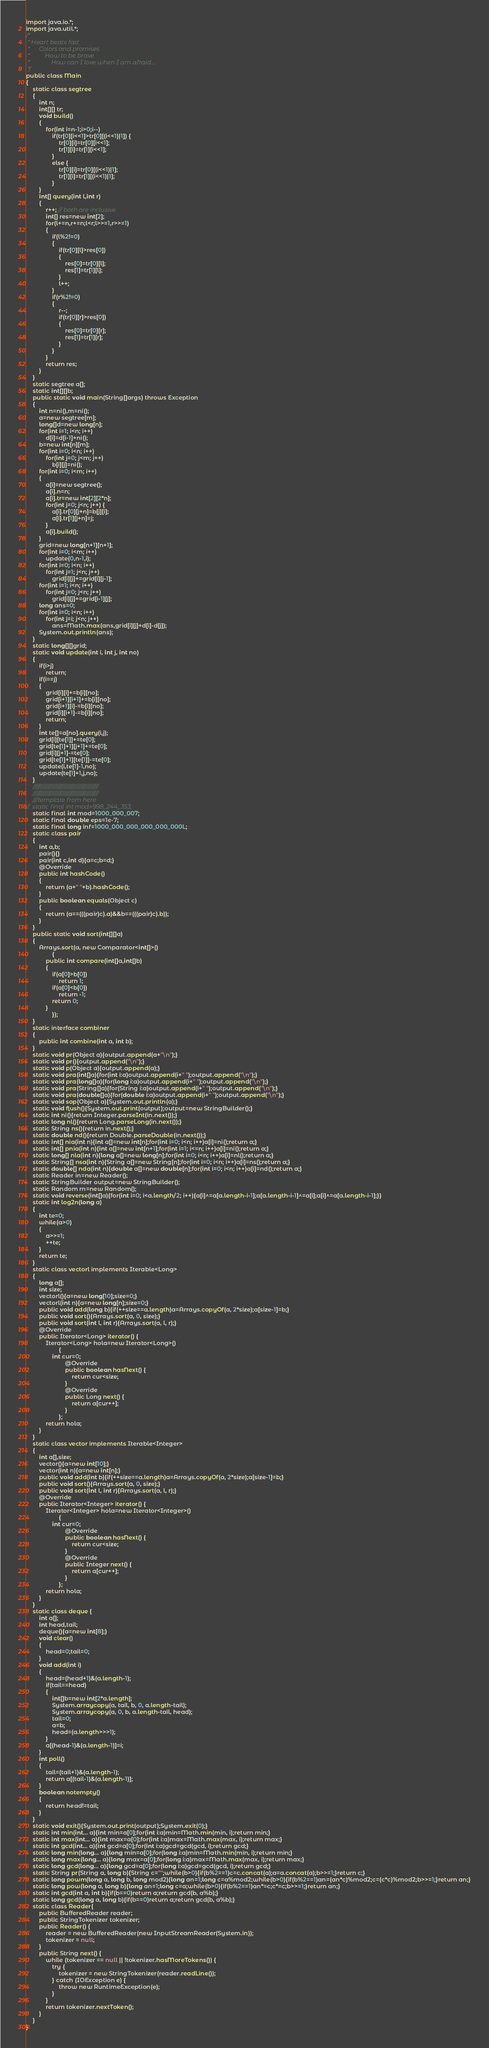Convert code to text. <code><loc_0><loc_0><loc_500><loc_500><_Java_>import java.io.*;
import java.util.*;
/*
 * Heart beats fast
 * 		Colors and promises
 * 			How to be brave
 * 				How can I love when I am afraid...
 */
public class Main
{
	static class segtree
	{ 
		int n;
		int[][] tr;
		void build()
		{
			for(int i=n-1;i>0;i--)
				if(tr[0][i<<1]>tr[0][(i<<1)|1]) {
					tr[0][i]=tr[0][i<<1];
					tr[1][i]=tr[1][i<<1];
				}
				else {
					tr[0][i]=tr[0][(i<<1)|1];
					tr[1][i]=tr[1][(i<<1)|1];	
				}
		}
		int[] query(int l,int r)
		{
			r++; // both are inclusive
			int[] res=new int[2];
			for(l+=n,r+=n;l<r;l>>=1,r>>=1)
			{
				if(l%2!=0) 
				{
					if(tr[0][l]>res[0])
					{
						res[0]=tr[0][l];
						res[1]=tr[1][l];
					}
					l++;
				}
				if(r%2!=0)
				{
					r--;
					if(tr[0][r]>res[0])
					{
						res[0]=tr[0][r];
						res[1]=tr[1][r];
					}
				}
			}
			return res;
		}
	}
	static segtree a[];
	static int[][]b;
	public static void main(String[]args) throws Exception
	{
		int n=ni(),m=ni();
		a=new segtree[m];
		long[]d=new long[n];
		for(int i=1; i<n; i++)
			d[i]=d[i-1]+ni();
		b=new int[n][m];
		for(int i=0; i<n; i++)
			for(int j=0; j<m; j++)
				b[i][j]=ni();
		for(int i=0; i<m; i++)
		{
			a[i]=new segtree();
			a[i].n=n;
			a[i].tr=new int[2][2*n];
			for(int j=0; j<n; j++) {
				a[i].tr[0][j+n]=b[j][i];
				a[i].tr[1][j+n]=j;
			}
			a[i].build();
		}
		grid=new long[n+1][n+1];
		for(int i=0; i<m; i++)
			update(0,n-1,i);
		for(int i=0; i<n; i++)
			for(int j=1; j<n; j++)
				grid[i][j]+=grid[i][j-1];
		for(int i=1; i<n; i++)
			for(int j=0; j<n; j++)
				grid[i][j]+=grid[i-1][j];
		long ans=0;
		for(int i=0; i<n; i++)
			for(int j=i; j<n; j++)
				ans=Math.max(ans,grid[i][j]+d[i]-d[j]);
		System.out.println(ans);
	}
	static long[][]grid;
	static void update(int i, int j, int no)
	{
		if(i>j)
			return;
		if(i==j)
		{
			grid[i][i]+=b[i][no];
			grid[i+1][i+1]+=b[i][no];
			grid[i+1][i]-=b[i][no];
			grid[i][i+1]-=b[i][no];
			return;
		}
		int te[]=a[no].query(i,j);
		grid[i][te[1]]+=te[0];
		grid[te[1]+1][j+1]+=te[0];
		grid[i][j+1]-=te[0];
		grid[te[1]+1][te[1]]-=te[0];
		update(i,te[1]-1,no);
		update(te[1]+1,j,no);
	}
	///////////////////////////////////////////
	///////////////////////////////////////////
	///template from here
//	static final int mod=998_244_353;
	static final int mod=1000_000_007;
	static final double eps=1e-7;
	static final long inf=1000_000_000_000_000_000L;
	static class pair
	{
		int a,b;
		pair(){}
		pair(int c,int d){a=c;b=d;}
		@Override
		public int hashCode()
		{
			return (a+" "+b).hashCode();
		}
		public boolean equals(Object c)
		{
			return (a==(((pair)c).a)&&b==(((pair)c).b));
		}
	}
	public static void sort(int[][]a)
	{
		Arrays.sort(a, new Comparator<int[]>()
				{
			public int compare(int[]a,int[]b)
			{
				if(a[0]>b[0])
					return 1;
				if(a[0]<b[0])
					return -1;
				return 0;
			}
				});
	}
	static interface combiner
	{
		public int combine(int a, int b);
	}
	static void pr(Object a){output.append(a+"\n");}
	static void pr(){output.append("\n");}
	static void p(Object a){output.append(a);}
	static void pra(int[]a){for(int i:a)output.append(i+" ");output.append("\n");}
	static void pra(long[]a){for(long i:a)output.append(i+" ");output.append("\n");}
	static void pra(String[]a){for(String i:a)output.append(i+" ");output.append("\n");}
	static void pra(double[]a){for(double i:a)output.append(i+" ");output.append("\n");}
	static void sop(Object a){System.out.println(a);}
	static void flush(){System.out.print(output);output=new StringBuilder();}
	static int ni(){return Integer.parseInt(in.next());}
	static long nl(){return Long.parseLong(in.next());}
	static String ns(){return in.next();}
	static double nd(){return Double.parseDouble(in.next());}
	static int[] nia(int n){int a[]=new int[n];for(int i=0; i<n; i++)a[i]=ni();return a;}
	static int[] pnia(int n){int a[]=new int[n+1];for(int i=1; i<=n; i++)a[i]=ni();return a;}
	static long[] nla(int n){long a[]=new long[n];for(int i=0; i<n; i++)a[i]=nl();return a;}
	static String[] nsa(int n){String a[]=new String[n];for(int i=0; i<n; i++)a[i]=ns();return a;}
	static double[] nda(int n){double a[]=new double[n];for(int i=0; i<n; i++)a[i]=nd();return a;}
	static Reader in=new Reader();
	static StringBuilder output=new StringBuilder();
	static Random rn=new Random();
	static void reverse(int[]a){for(int i=0; i<a.length/2; i++){a[i]^=a[a.length-i-1];a[a.length-i-1]^=a[i];a[i]^=a[a.length-i-1];}}
	static int log2n(long a)
	{
		int te=0;
		while(a>0)
		{
			a>>=1;
			++te;
		}
		return te;
	}
	static class vectorl implements Iterable<Long>
	{
		long a[];
		int size;
		vectorl(){a=new long[10];size=0;}
		vectorl(int n){a=new long[n];size=0;}
		public void add(long b){if(++size==a.length)a=Arrays.copyOf(a, 2*size);a[size-1]=b;}
		public void sort(){Arrays.sort(a, 0, size);}
		public void sort(int l, int r){Arrays.sort(a, l, r);}
		@Override
		public Iterator<Long> iterator() {
			Iterator<Long> hola=new Iterator<Long>()
					{
				int cur=0;
						@Override
						public boolean hasNext() {
							return cur<size;
						}
						@Override
						public Long next() {
							return a[cur++];
						}				
					};
			return hola;
		}
	}
	static class vector implements Iterable<Integer>
	{
		int a[],size;
		vector(){a=new int[10];}
		vector(int n){a=new int[n];}
		public void add(int b){if(++size==a.length)a=Arrays.copyOf(a, 2*size);a[size-1]=b;}
		public void sort(){Arrays.sort(a, 0, size);}
		public void sort(int l, int r){Arrays.sort(a, l, r);}
		@Override
		public Iterator<Integer> iterator() {
			Iterator<Integer> hola=new Iterator<Integer>()
					{
				int cur=0;
						@Override
						public boolean hasNext() {
							return cur<size;
						}
						@Override
						public Integer next() {
							return a[cur++];
						}				
					};
			return hola;
		}
	}
	static class deque {
		int a[];
		int head,tail;
		deque(){a=new int[8];}
		void clear()
		{
			head=0;tail=0;
		}
		void add(int i)
		{	
			head=(head+1)&(a.length-1);
			if(tail==head)
			{
				int[]b=new int[2*a.length];
				System.arraycopy(a, tail, b, 0, a.length-tail);
				System.arraycopy(a, 0, b, a.length-tail, head);
				tail=0;
				a=b;
				head=(a.length>>>1);
			}
			a[(head-1)&(a.length-1)]=i;
		}
		int poll()
		{
			tail=(tail+1)&(a.length-1);
			return a[(tail-1)&(a.length-1)];
		}
		boolean notempty()
		{
			return head!=tail;
		}
	}
	static void exit(){System.out.print(output);System.exit(0);}
	static int min(int... a){int min=a[0];for(int i:a)min=Math.min(min, i);return min;}
	static int max(int... a){int max=a[0];for(int i:a)max=Math.max(max, i);return max;}	
	static int gcd(int... a){int gcd=a[0];for(int i:a)gcd=gcd(gcd, i);return gcd;}	
	static long min(long... a){long min=a[0];for(long i:a)min=Math.min(min, i);return min;}
	static long max(long... a){long max=a[0];for(long i:a)max=Math.max(max, i);return max;}	
	static long gcd(long... a){long gcd=a[0];for(long i:a)gcd=gcd(gcd, i);return gcd;}	
	static String pr(String a, long b){String c="";while(b>0){if(b%2==1)c=c.concat(a);a=a.concat(a);b>>=1;}return c;}
	static long powm(long a, long b, long mod2){long an=1;long c=a%mod2;while(b>0){if(b%2==1)an=(an*c)%mod2;c=(c*c)%mod2;b>>=1;}return an;}
	static long pow(long a, long b){long an=1;long c=a;while(b>0){if(b%2==1)an*=c;c*=c;b>>=1;}return an;}
	static int gcd(int a, int b){if(b==0)return a;return gcd(b, a%b);}
	static long gcd(long a, long b){if(b==0)return a;return gcd(b, a%b);}
	static class Reader{
        public BufferedReader reader;
        public StringTokenizer tokenizer;
        public Reader() {
            reader = new BufferedReader(new InputStreamReader(System.in));
            tokenizer = null;
        }
        public String next() {
            while (tokenizer == null || !tokenizer.hasMoreTokens()) {
                try {
                    tokenizer = new StringTokenizer(reader.readLine());
                } catch (IOException e) {
                    throw new RuntimeException(e);
                }
            }
            return tokenizer.nextToken();
        }
    }
}</code> 